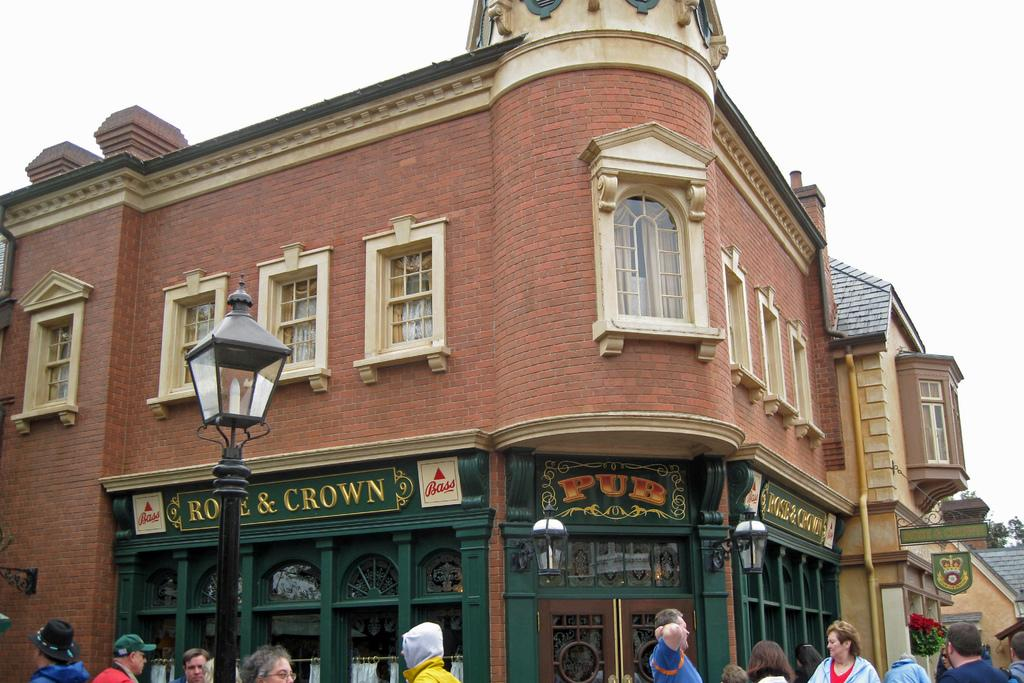What type of structure is in the image? There is a building in the image. What features can be observed on the building? The building has many windows and doors. What is happening in front of the building? There are people walking in front of the building. What can be seen above the building? The sky is visible above the building. What type of poison is being sprayed from the clouds in the image? There are no clouds or poison present in the image; it features a building with people walking in front of it. 